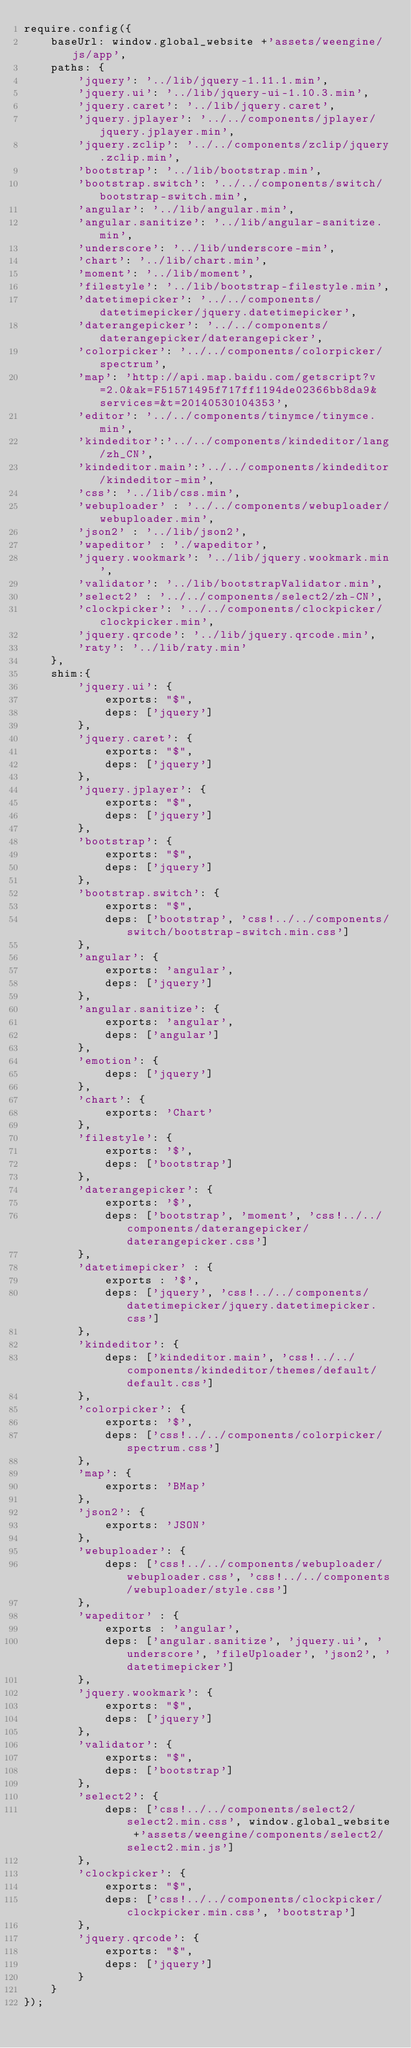<code> <loc_0><loc_0><loc_500><loc_500><_JavaScript_>require.config({
	baseUrl: window.global_website +'assets/weengine/js/app',
	paths: {
		'jquery': '../lib/jquery-1.11.1.min',
		'jquery.ui': '../lib/jquery-ui-1.10.3.min',
		'jquery.caret': '../lib/jquery.caret',
		'jquery.jplayer': '../../components/jplayer/jquery.jplayer.min',
		'jquery.zclip': '../../components/zclip/jquery.zclip.min',
		'bootstrap': '../lib/bootstrap.min',
		'bootstrap.switch': '../../components/switch/bootstrap-switch.min',
		'angular': '../lib/angular.min',
		'angular.sanitize': '../lib/angular-sanitize.min',
		'underscore': '../lib/underscore-min',
		'chart': '../lib/chart.min',
		'moment': '../lib/moment',
		'filestyle': '../lib/bootstrap-filestyle.min',
		'datetimepicker': '../../components/datetimepicker/jquery.datetimepicker',
		'daterangepicker': '../../components/daterangepicker/daterangepicker',
		'colorpicker': '../../components/colorpicker/spectrum',
		'map': 'http://api.map.baidu.com/getscript?v=2.0&ak=F51571495f717ff1194de02366bb8da9&services=&t=20140530104353',
		'editor': '../../components/tinymce/tinymce.min',
		'kindeditor':'../../components/kindeditor/lang/zh_CN',
		'kindeditor.main':'../../components/kindeditor/kindeditor-min',
		'css': '../lib/css.min',
		'webuploader' : '../../components/webuploader/webuploader.min',
		'json2' : '../lib/json2',
		'wapeditor' : './wapeditor',
		'jquery.wookmark': '../lib/jquery.wookmark.min',
		'validator': '../lib/bootstrapValidator.min',
		'select2' : '../../components/select2/zh-CN',
		'clockpicker': '../../components/clockpicker/clockpicker.min',
		'jquery.qrcode': '../lib/jquery.qrcode.min',
		'raty': '../lib/raty.min'
	},
	shim:{
		'jquery.ui': {
			exports: "$",
			deps: ['jquery']
		},
		'jquery.caret': {
			exports: "$",
			deps: ['jquery']
		},
		'jquery.jplayer': {
			exports: "$",
			deps: ['jquery']
		},
		'bootstrap': {
			exports: "$",
			deps: ['jquery']
		},
		'bootstrap.switch': {
			exports: "$",
			deps: ['bootstrap', 'css!../../components/switch/bootstrap-switch.min.css']
		},
		'angular': {
			exports: 'angular',
			deps: ['jquery']
		},
		'angular.sanitize': {
			exports: 'angular',
			deps: ['angular']
		},
		'emotion': {
			deps: ['jquery']
		},
		'chart': {
			exports: 'Chart'
		},
		'filestyle': {
			exports: '$',
			deps: ['bootstrap']
		},
		'daterangepicker': {
			exports: '$',
			deps: ['bootstrap', 'moment', 'css!../../components/daterangepicker/daterangepicker.css']
		},
		'datetimepicker' : {
			exports : '$',
			deps: ['jquery', 'css!../../components/datetimepicker/jquery.datetimepicker.css']
		},
		'kindeditor': {
			deps: ['kindeditor.main', 'css!../../components/kindeditor/themes/default/default.css']
		},
		'colorpicker': {
			exports: '$',
			deps: ['css!../../components/colorpicker/spectrum.css']
		},
		'map': {
			exports: 'BMap'
		},
		'json2': {
			exports: 'JSON'
		},
		'webuploader': {
			deps: ['css!../../components/webuploader/webuploader.css', 'css!../../components/webuploader/style.css']
		},
		'wapeditor' : {
			exports : 'angular',
			deps: ['angular.sanitize', 'jquery.ui', 'underscore', 'fileUploader', 'json2', 'datetimepicker']
		},
		'jquery.wookmark': {
			exports: "$",
			deps: ['jquery']
		},
		'validator': {
			exports: "$",
			deps: ['bootstrap']
		},
		'select2': {
			deps: ['css!../../components/select2/select2.min.css', window.global_website +'assets/weengine/components/select2/select2.min.js']
		},
		'clockpicker': {
			exports: "$",
			deps: ['css!../../components/clockpicker/clockpicker.min.css', 'bootstrap']
		},
		'jquery.qrcode': {
			exports: "$",
			deps: ['jquery']
		}
	}
});</code> 